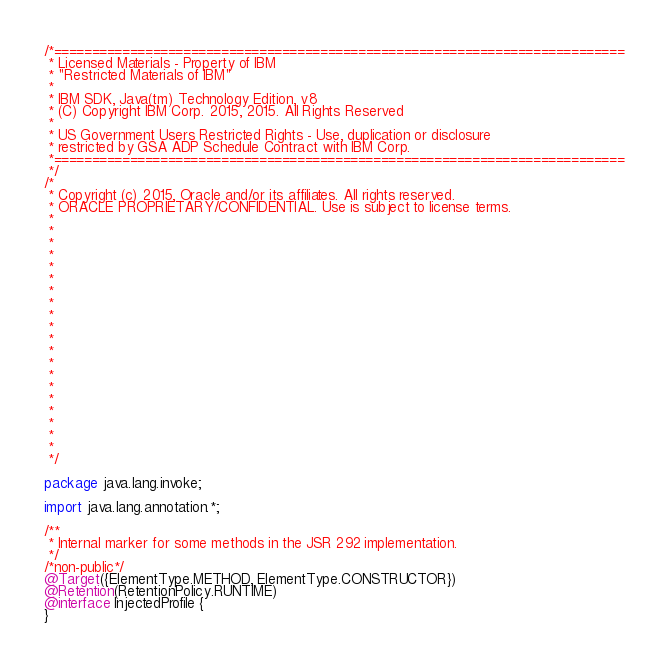Convert code to text. <code><loc_0><loc_0><loc_500><loc_500><_Java_>/*===========================================================================
 * Licensed Materials - Property of IBM
 * "Restricted Materials of IBM"
 * 
 * IBM SDK, Java(tm) Technology Edition, v8
 * (C) Copyright IBM Corp. 2015, 2015. All Rights Reserved
 *
 * US Government Users Restricted Rights - Use, duplication or disclosure
 * restricted by GSA ADP Schedule Contract with IBM Corp.
 *===========================================================================
 */
/*
 * Copyright (c) 2015, Oracle and/or its affiliates. All rights reserved.
 * ORACLE PROPRIETARY/CONFIDENTIAL. Use is subject to license terms.
 *
 *
 *
 *
 *
 *
 *
 *
 *
 *
 *
 *
 *
 *
 *
 *
 *
 *
 *
 *
 */

package java.lang.invoke;

import java.lang.annotation.*;

/**
 * Internal marker for some methods in the JSR 292 implementation.
 */
/*non-public*/
@Target({ElementType.METHOD, ElementType.CONSTRUCTOR})
@Retention(RetentionPolicy.RUNTIME)
@interface InjectedProfile {
}
</code> 